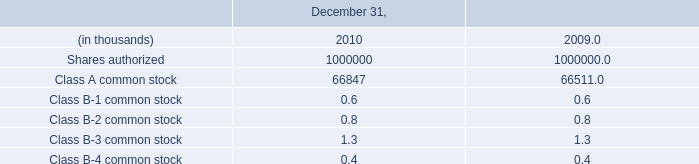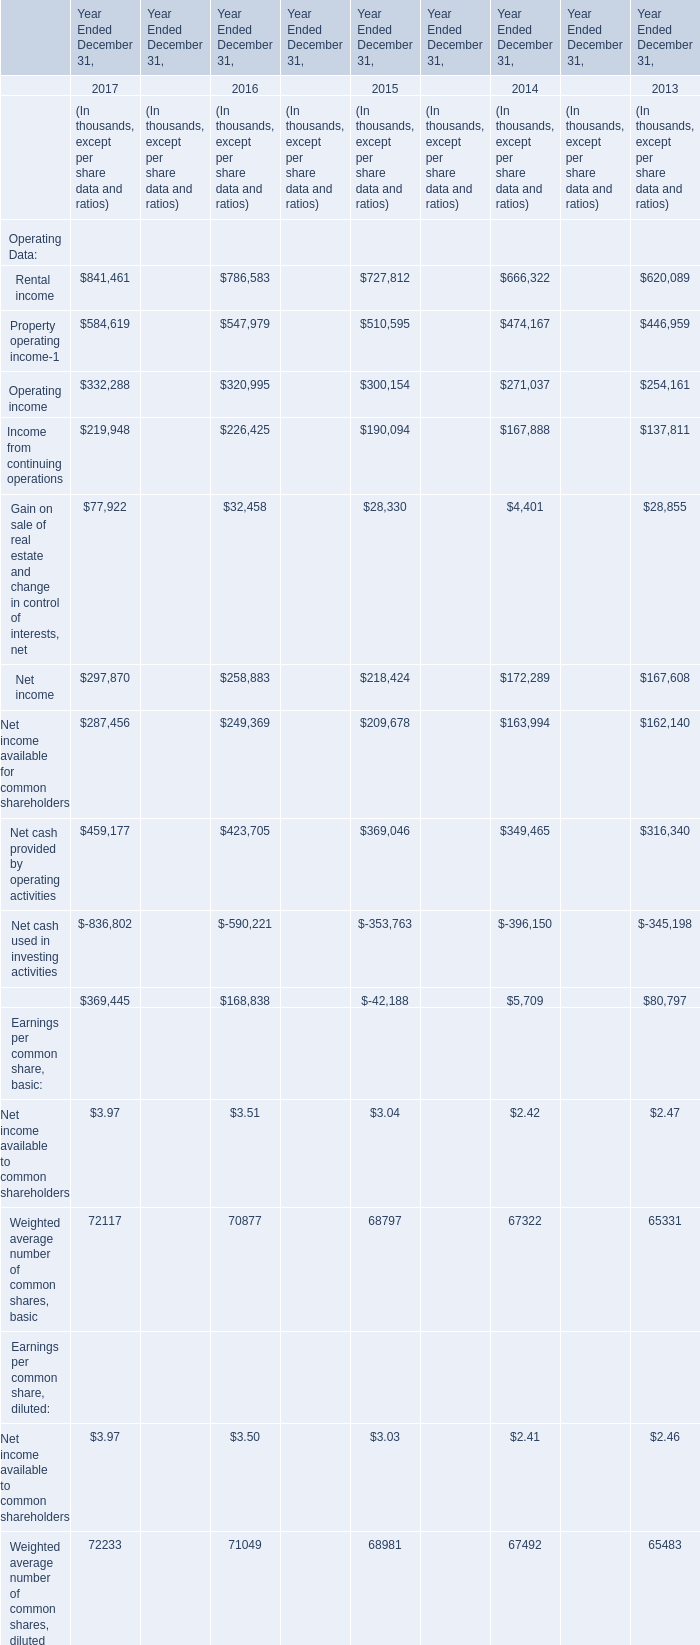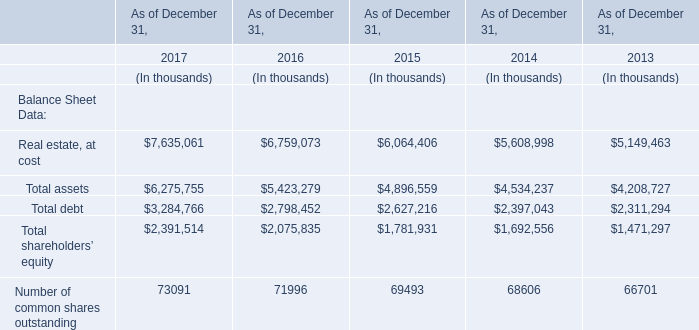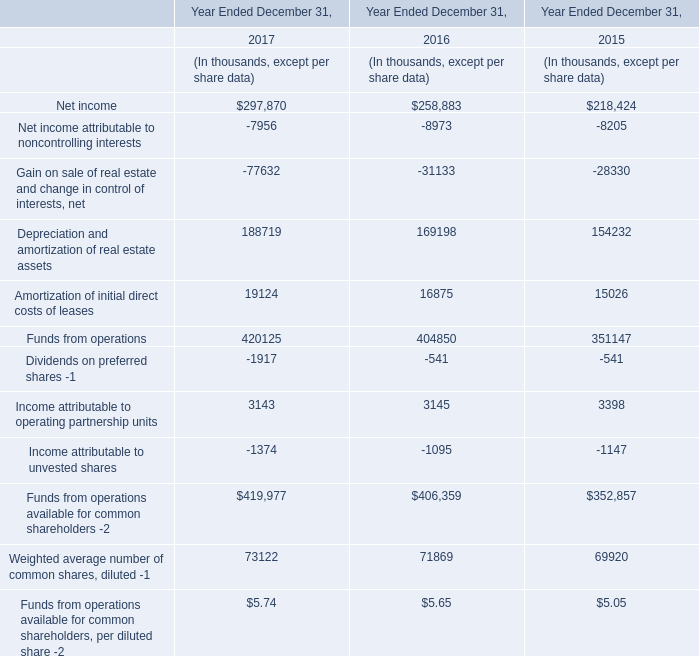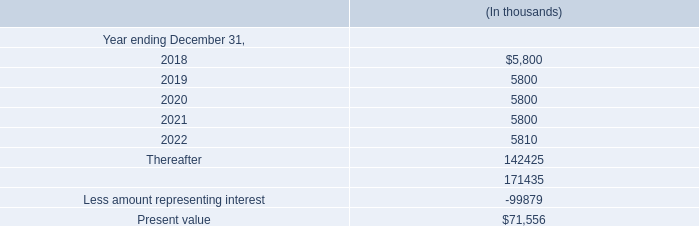In the year where the value of Total assets is the highest, what's the value of Total debt? (in thousand) 
Answer: 3284766. 